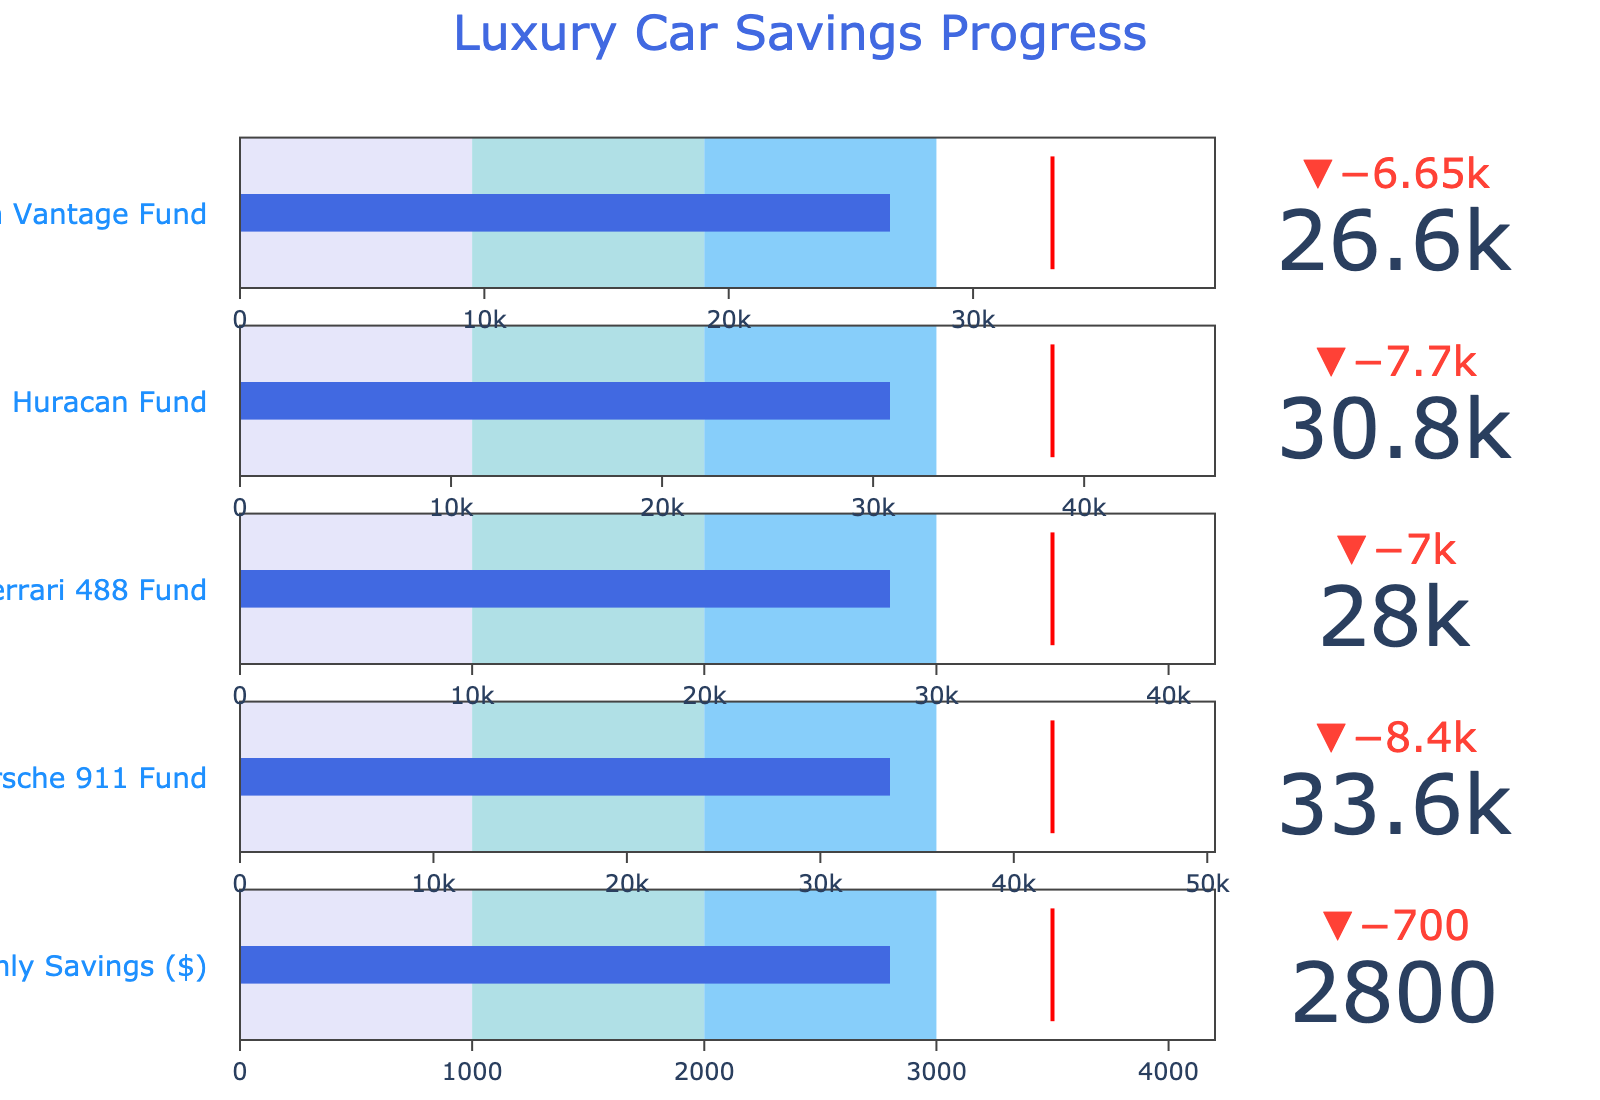What is the title of the figure? The title is usually displayed at the top of a chart or graph. Here, the title is provided as "Luxury Car Savings Progress".
Answer: Luxury Car Savings Progress What is the actual amount saved for the Lamborghini Huracan Fund? Examine the "Actual" value for the Lamborghini Huracan Fund in the data.
Answer: $30,800 Which car fund has the highest target amount? Compare the "Target" values for each car fund listed and identify the highest one. In this case, look for the highest numerical value in the "Target" column.
Answer: Porsche 911 Fund For the Monthly Savings target, how far is the actual savings from meeting the target? Subtract the "Actual" savings for Monthly Savings from its "Target" to find the difference: 3500 - 2800.
Answer: $700 How much more has been saved for the Ferrari 488 Fund compared to the Aston Martin Vantage Fund? Subtract the "Actual" savings of the Aston Martin Vantage Fund from the "Actual" savings of the Ferrari 488 Fund: 28000 - 26600.
Answer: $1,400 What are the range values used in the gauge for the Ferrari 488 Fund? Identify the "Range" parameters for the Ferrari 488 Fund. These are Range1, Range2, and Range3 values: 10000, 20000, 30000.
Answer: 10,000, 20,000, 30,000 How much more needs to be saved to meet the target for the Porsche 911 Fund? Subtract the "Actual" savings from the "Target" for the Porsche 911 Fund: 42000 - 33600.
Answer: $8,400 